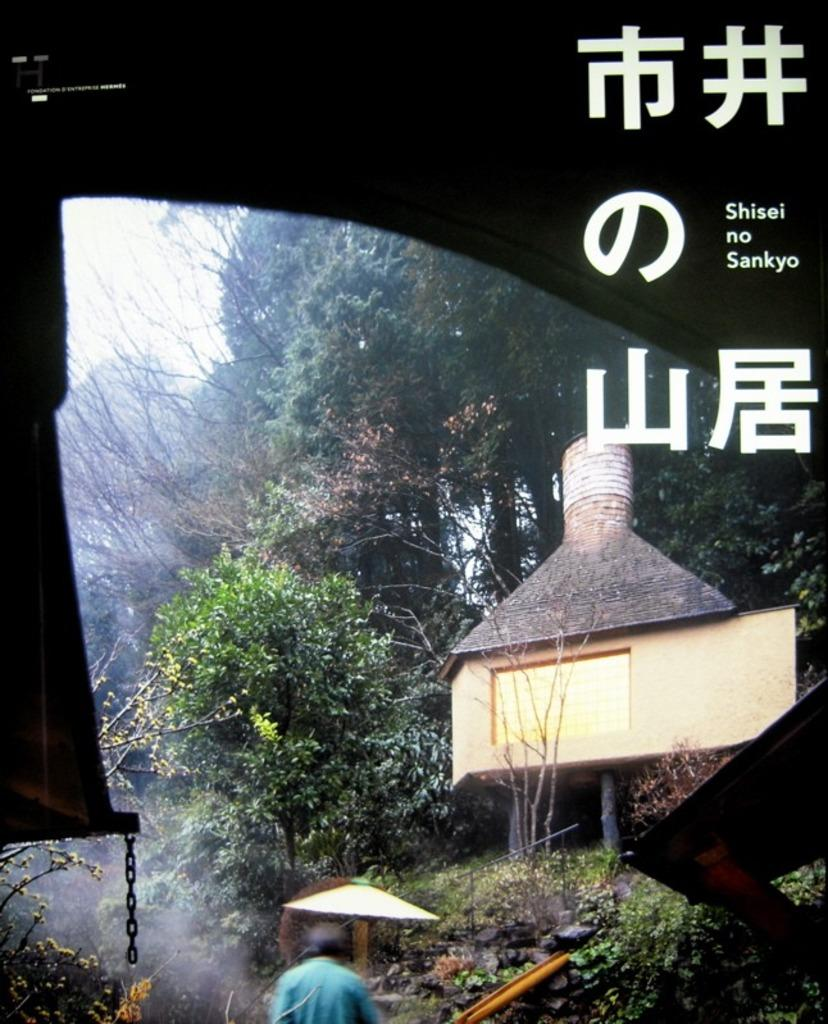What type of natural elements can be seen in the image? There are many trees and plants in the image. What type of man-made structures are visible in the image? There are houses and a wall in the image. What is the human being at the bottom of the image doing? The human being is visible at the bottom of the image, but their actions are not clear from the provided facts. What is the chain used for in the image? The purpose of the chain in the image is not specified in the provided facts. What type of pocket can be seen in the image? There is no pocket present in the image. What meal is being prepared in the image? There is no meal preparation visible in the image. 